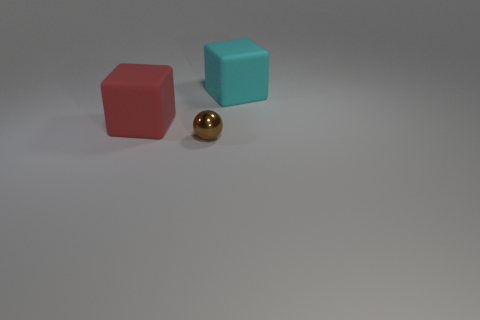Are there any other things that are the same material as the tiny ball?
Ensure brevity in your answer.  No. Are there fewer matte things that are to the left of the red rubber object than big yellow shiny things?
Ensure brevity in your answer.  No. Is the shape of the rubber object that is on the left side of the small brown ball the same as  the tiny brown thing?
Offer a terse response. No. Is there anything else that is the same color as the small sphere?
Your answer should be compact. No. The thing that is made of the same material as the red block is what size?
Provide a succinct answer. Large. There is a big thing in front of the big cube right of the big thing that is to the left of the small object; what is its material?
Your response must be concise. Rubber. Are there fewer tiny spheres than cubes?
Keep it short and to the point. Yes. Is the red block made of the same material as the brown object?
Your response must be concise. No. There is a matte thing in front of the cyan rubber thing; what number of cyan matte blocks are in front of it?
Provide a succinct answer. 0. There is another block that is the same size as the red block; what is its color?
Ensure brevity in your answer.  Cyan. 